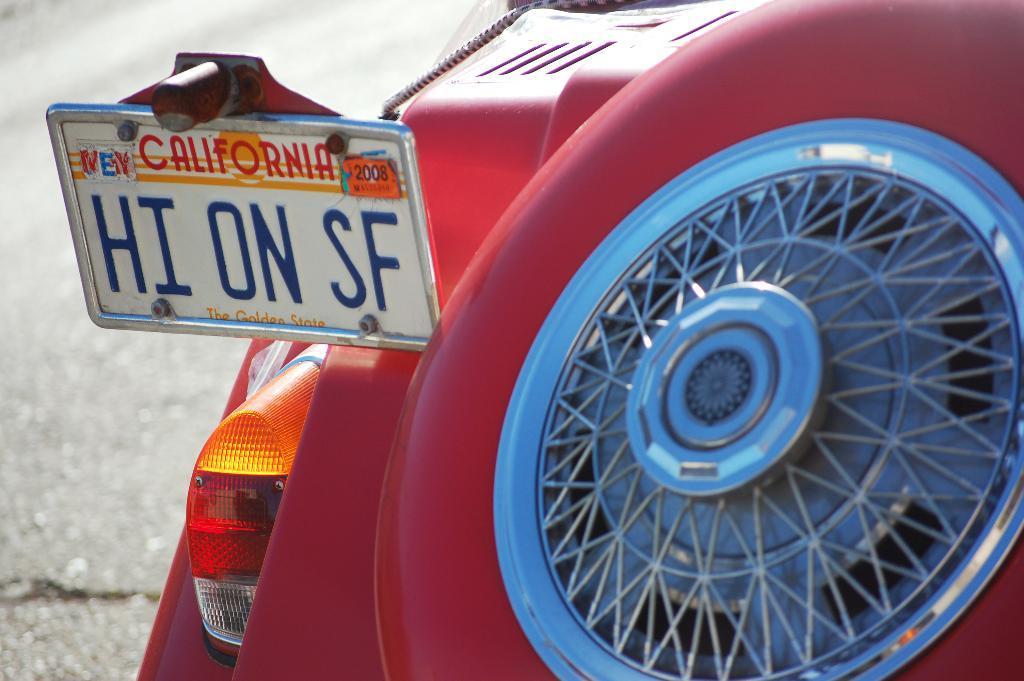How would you summarize this image in a sentence or two? In this image we can see a red color object and a board on which some text was written. On the right side of the image we can see a wheel type of object. 